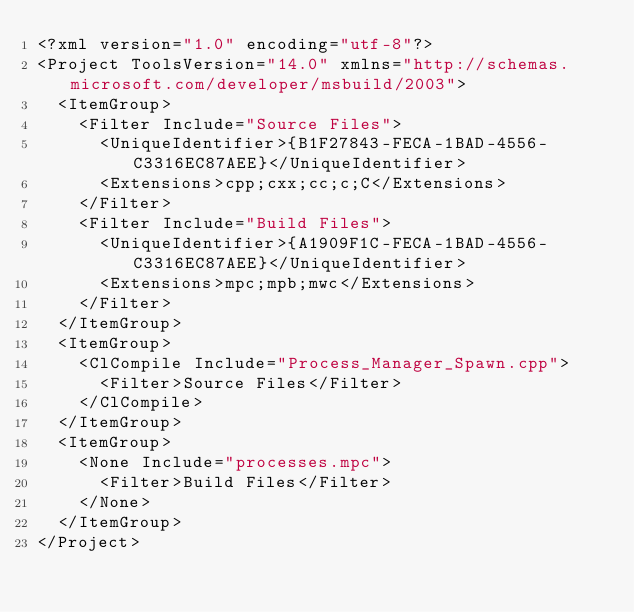<code> <loc_0><loc_0><loc_500><loc_500><_XML_><?xml version="1.0" encoding="utf-8"?>
<Project ToolsVersion="14.0" xmlns="http://schemas.microsoft.com/developer/msbuild/2003">
  <ItemGroup>
    <Filter Include="Source Files">
      <UniqueIdentifier>{B1F27843-FECA-1BAD-4556-C3316EC87AEE}</UniqueIdentifier>
      <Extensions>cpp;cxx;cc;c;C</Extensions>
    </Filter>
    <Filter Include="Build Files">
      <UniqueIdentifier>{A1909F1C-FECA-1BAD-4556-C3316EC87AEE}</UniqueIdentifier>
      <Extensions>mpc;mpb;mwc</Extensions>
    </Filter>
  </ItemGroup>
  <ItemGroup>
    <ClCompile Include="Process_Manager_Spawn.cpp">
      <Filter>Source Files</Filter>
    </ClCompile>
  </ItemGroup>
  <ItemGroup>
    <None Include="processes.mpc">
      <Filter>Build Files</Filter>
    </None>
  </ItemGroup>
</Project>
</code> 